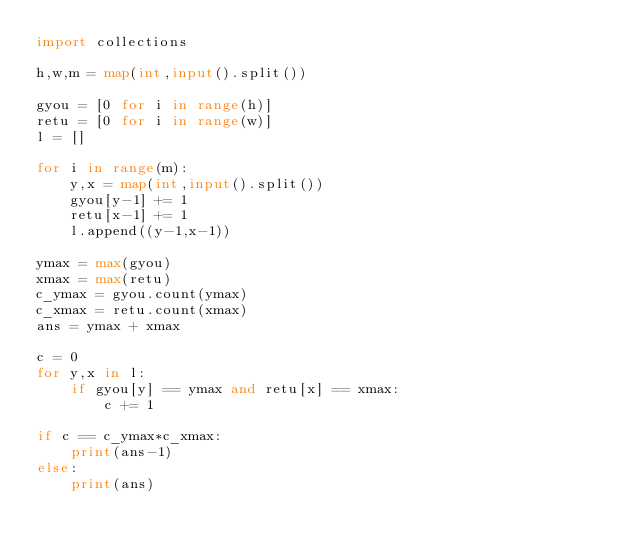Convert code to text. <code><loc_0><loc_0><loc_500><loc_500><_Python_>import collections

h,w,m = map(int,input().split())

gyou = [0 for i in range(h)]
retu = [0 for i in range(w)]
l = []

for i in range(m):
    y,x = map(int,input().split())
    gyou[y-1] += 1
    retu[x-1] += 1
    l.append((y-1,x-1))

ymax = max(gyou)
xmax = max(retu)
c_ymax = gyou.count(ymax)
c_xmax = retu.count(xmax)
ans = ymax + xmax

c = 0
for y,x in l:
    if gyou[y] == ymax and retu[x] == xmax:
        c += 1

if c == c_ymax*c_xmax:
    print(ans-1)
else:
    print(ans)</code> 